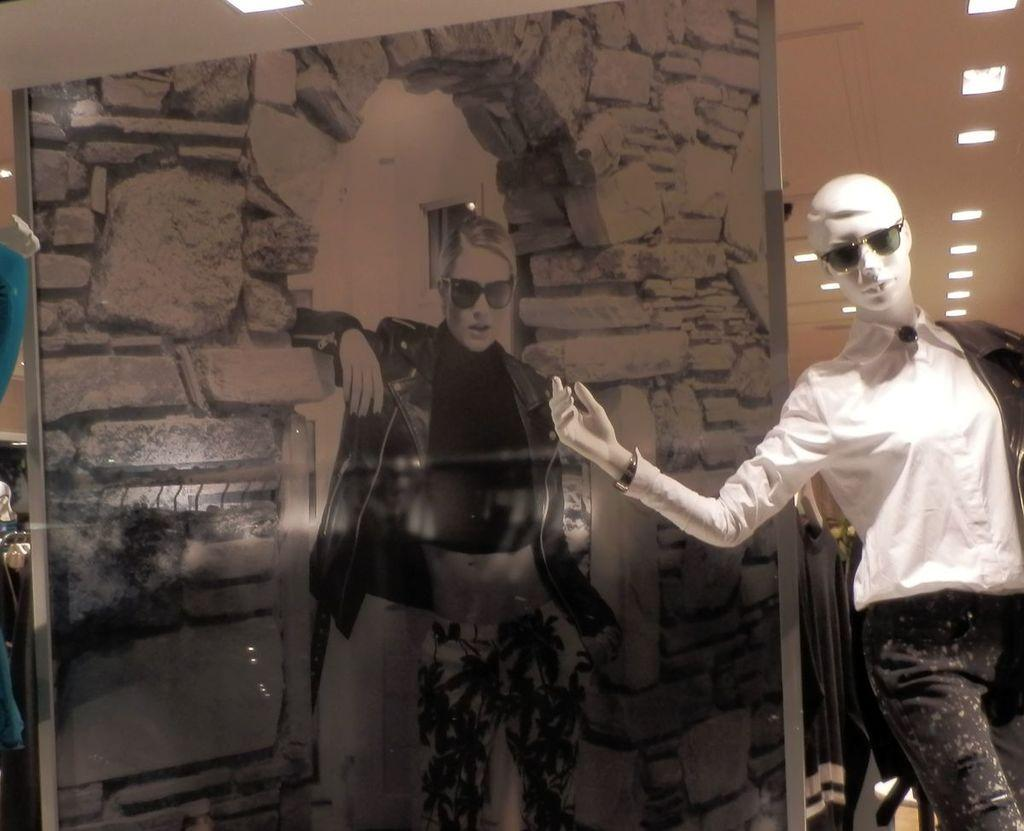What can be found in the show room? There is a mannequin in the show room. What is the mannequin wearing? The mannequin is wearing a white dress. What other artwork is present in the show room? There is a painting of a person in the show room. Where is the painting located in relation to the mannequin? The painting is behind the mannequin. What can be seen near the ceiling in the show room? There are lights visible near the ceiling. Is there a veil covering the mannequin's face in the image? No, there is no veil covering the mannequin's face in the image. What type of drain is visible in the show room? There is no drain present in the show room; the image only shows a mannequin, a painting, and lights near the ceiling. 